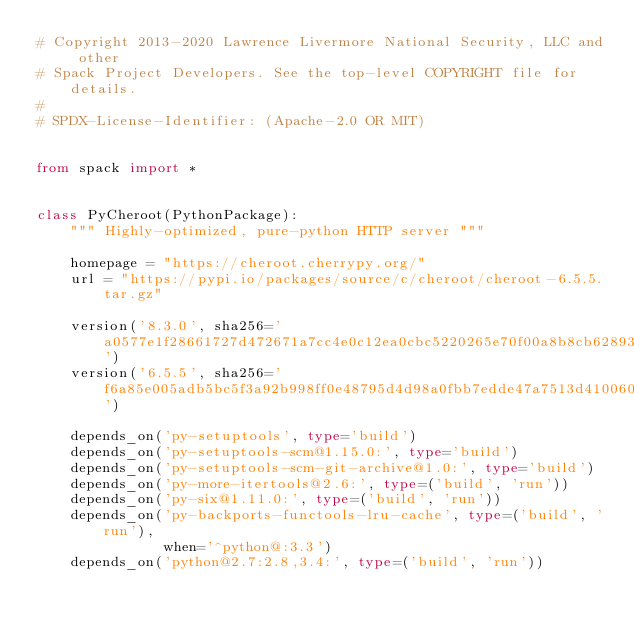<code> <loc_0><loc_0><loc_500><loc_500><_Python_># Copyright 2013-2020 Lawrence Livermore National Security, LLC and other
# Spack Project Developers. See the top-level COPYRIGHT file for details.
#
# SPDX-License-Identifier: (Apache-2.0 OR MIT)


from spack import *


class PyCheroot(PythonPackage):
    """ Highly-optimized, pure-python HTTP server """

    homepage = "https://cheroot.cherrypy.org/"
    url = "https://pypi.io/packages/source/c/cheroot/cheroot-6.5.5.tar.gz"

    version('8.3.0', sha256='a0577e1f28661727d472671a7cc4e0c12ea0cbc5220265e70f00a8b8cb628931')
    version('6.5.5', sha256='f6a85e005adb5bc5f3a92b998ff0e48795d4d98a0fbb7edde47a7513d4100601')

    depends_on('py-setuptools', type='build')
    depends_on('py-setuptools-scm@1.15.0:', type='build')
    depends_on('py-setuptools-scm-git-archive@1.0:', type='build')
    depends_on('py-more-itertools@2.6:', type=('build', 'run'))
    depends_on('py-six@1.11.0:', type=('build', 'run'))
    depends_on('py-backports-functools-lru-cache', type=('build', 'run'),
               when='^python@:3.3')
    depends_on('python@2.7:2.8,3.4:', type=('build', 'run'))
</code> 